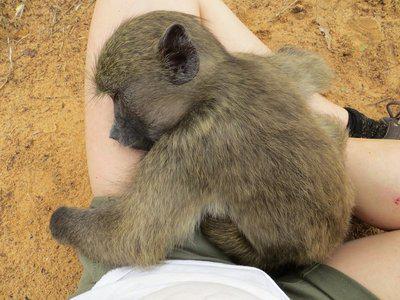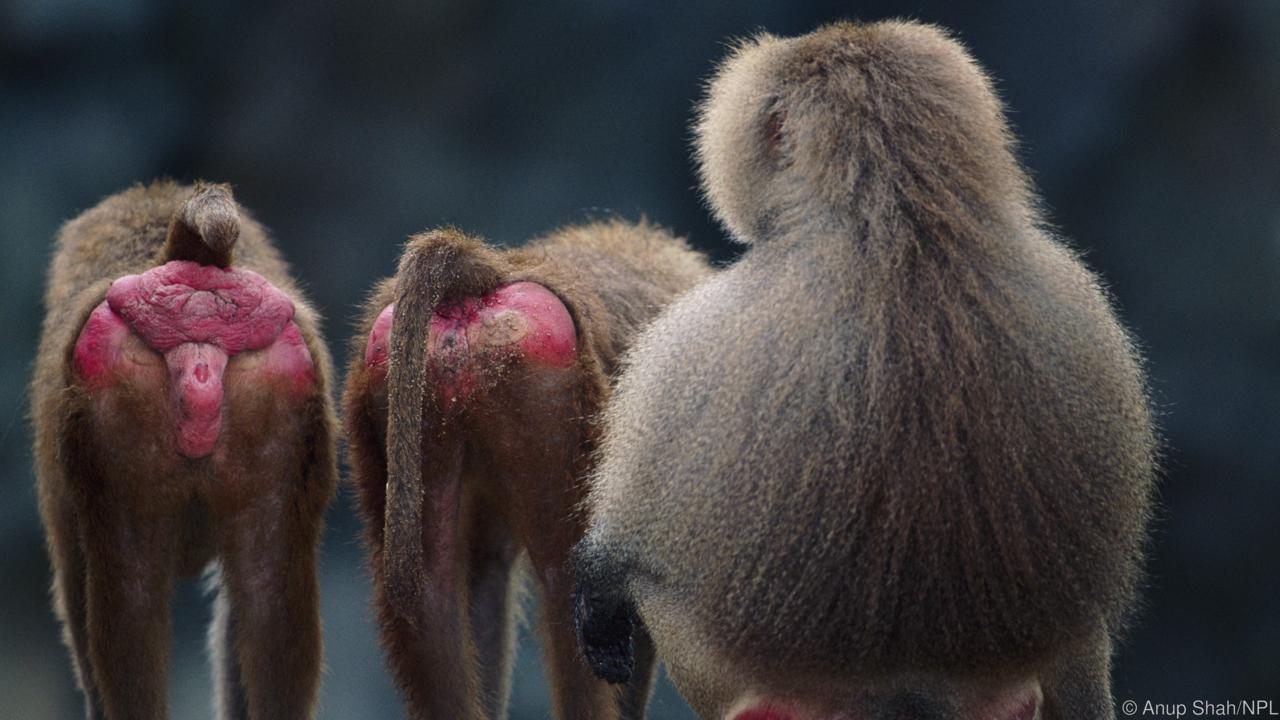The first image is the image on the left, the second image is the image on the right. For the images shown, is this caption "There is a baby monkey in each image." true? Answer yes or no. No. The first image is the image on the left, the second image is the image on the right. Given the left and right images, does the statement "All images include a baby baboon, and one image clearly shows a baby baboon with an adult baboon." hold true? Answer yes or no. No. 